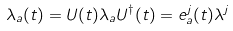<formula> <loc_0><loc_0><loc_500><loc_500>\lambda _ { a } ( t ) = U ( t ) \lambda _ { a } U ^ { \dagger } ( t ) = { e } _ { a } ^ { j } ( t ) \lambda ^ { j }</formula> 